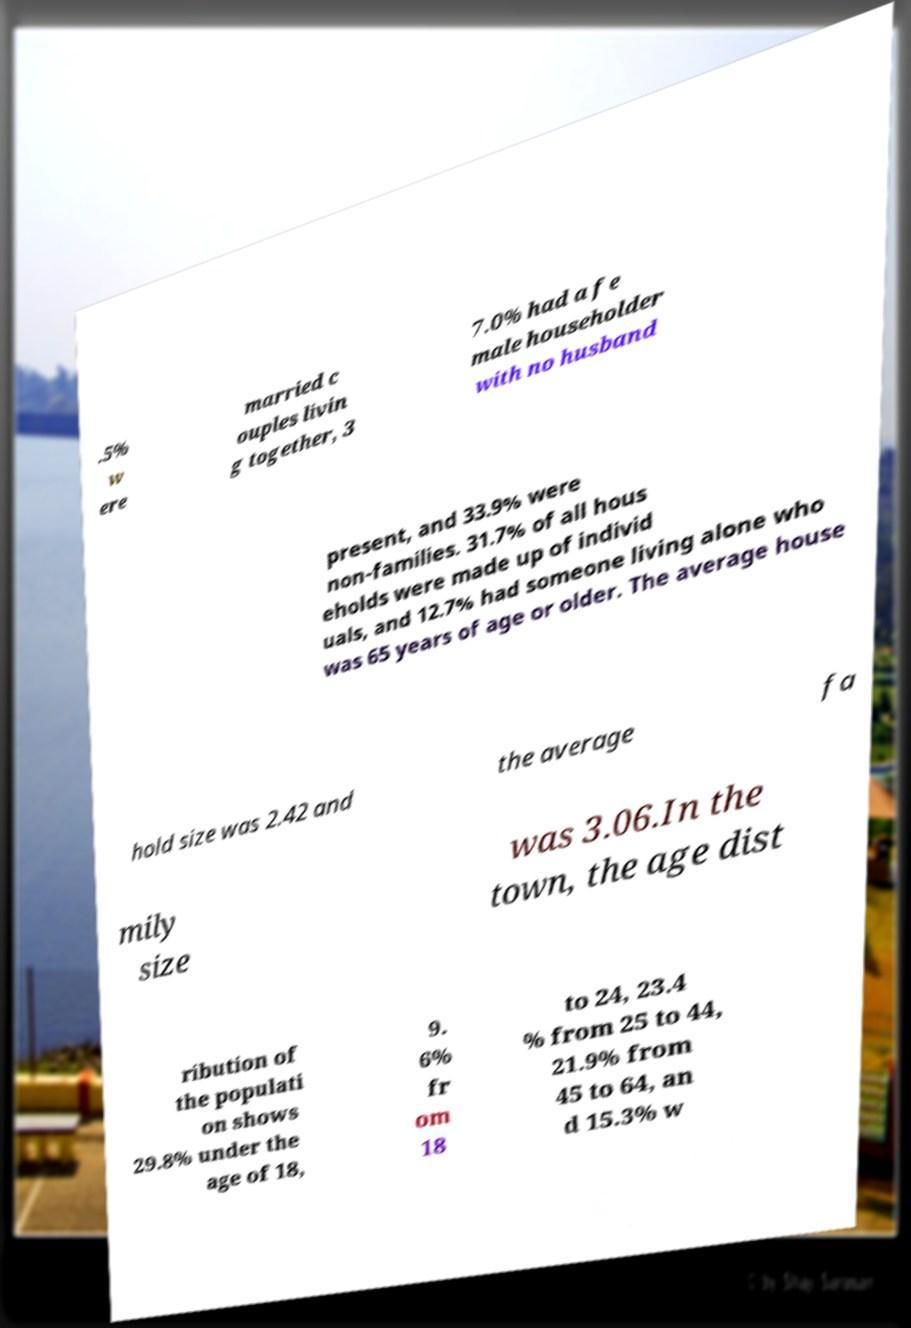For documentation purposes, I need the text within this image transcribed. Could you provide that? .5% w ere married c ouples livin g together, 3 7.0% had a fe male householder with no husband present, and 33.9% were non-families. 31.7% of all hous eholds were made up of individ uals, and 12.7% had someone living alone who was 65 years of age or older. The average house hold size was 2.42 and the average fa mily size was 3.06.In the town, the age dist ribution of the populati on shows 29.8% under the age of 18, 9. 6% fr om 18 to 24, 23.4 % from 25 to 44, 21.9% from 45 to 64, an d 15.3% w 